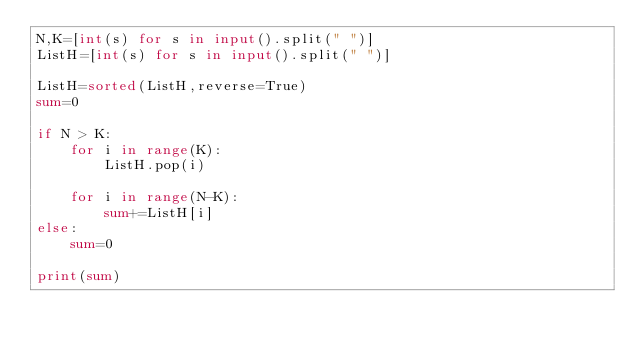<code> <loc_0><loc_0><loc_500><loc_500><_Python_>N,K=[int(s) for s in input().split(" ")]
ListH=[int(s) for s in input().split(" ")]

ListH=sorted(ListH,reverse=True)
sum=0

if N > K:
    for i in range(K):
        ListH.pop(i)

    for i in range(N-K):
        sum+=ListH[i]
else:
    sum=0
    
print(sum)</code> 